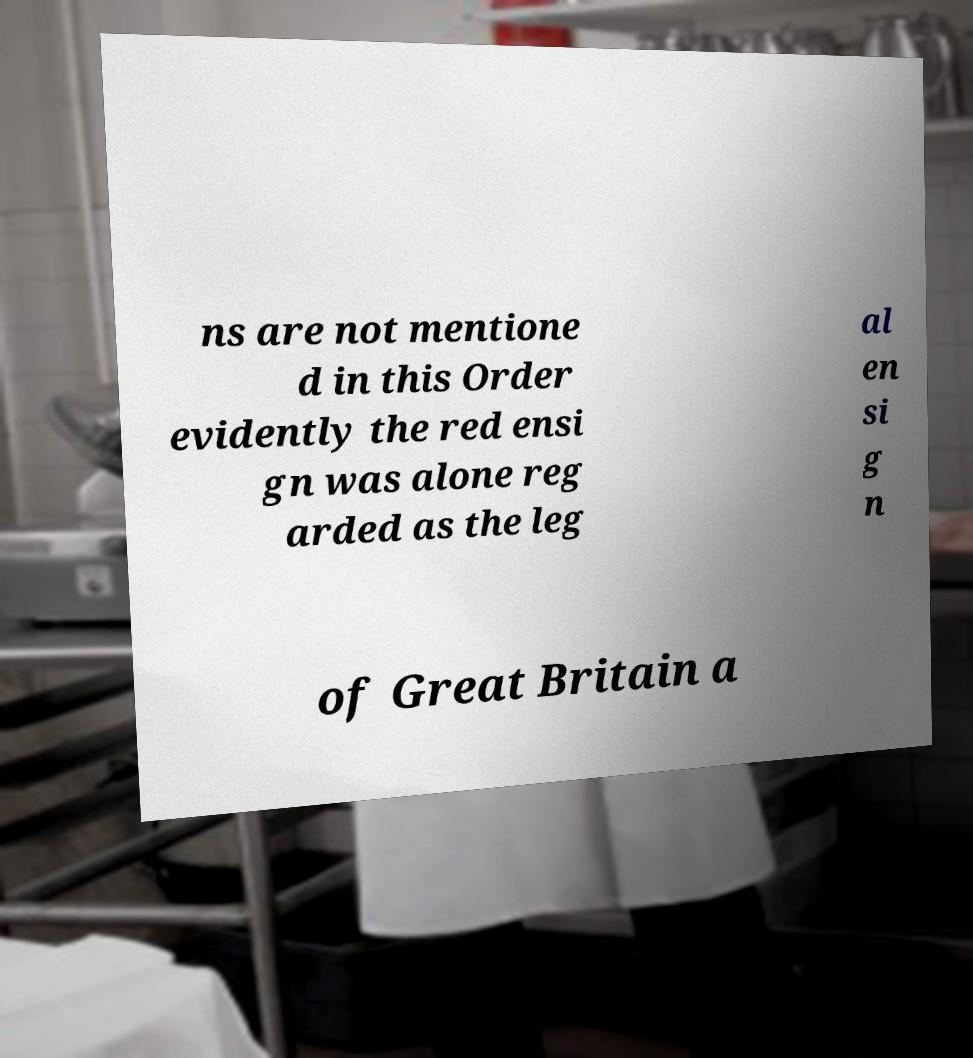For documentation purposes, I need the text within this image transcribed. Could you provide that? ns are not mentione d in this Order evidently the red ensi gn was alone reg arded as the leg al en si g n of Great Britain a 